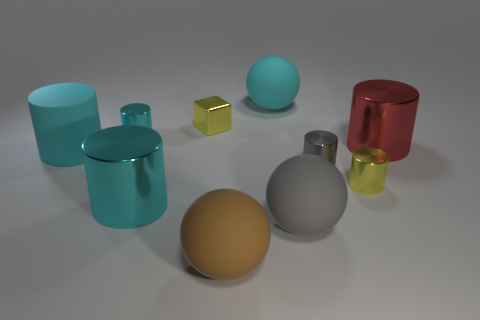Subtract all big cyan shiny cylinders. How many cylinders are left? 5 Subtract 3 cylinders. How many cylinders are left? 3 Subtract all gray cylinders. How many cylinders are left? 5 Subtract all cylinders. How many objects are left? 4 Subtract all gray balls. How many cyan cylinders are left? 3 Subtract all large purple balls. Subtract all tiny cyan objects. How many objects are left? 9 Add 1 yellow cylinders. How many yellow cylinders are left? 2 Add 5 big shiny cylinders. How many big shiny cylinders exist? 7 Subtract 0 cyan blocks. How many objects are left? 10 Subtract all purple cylinders. Subtract all cyan spheres. How many cylinders are left? 6 